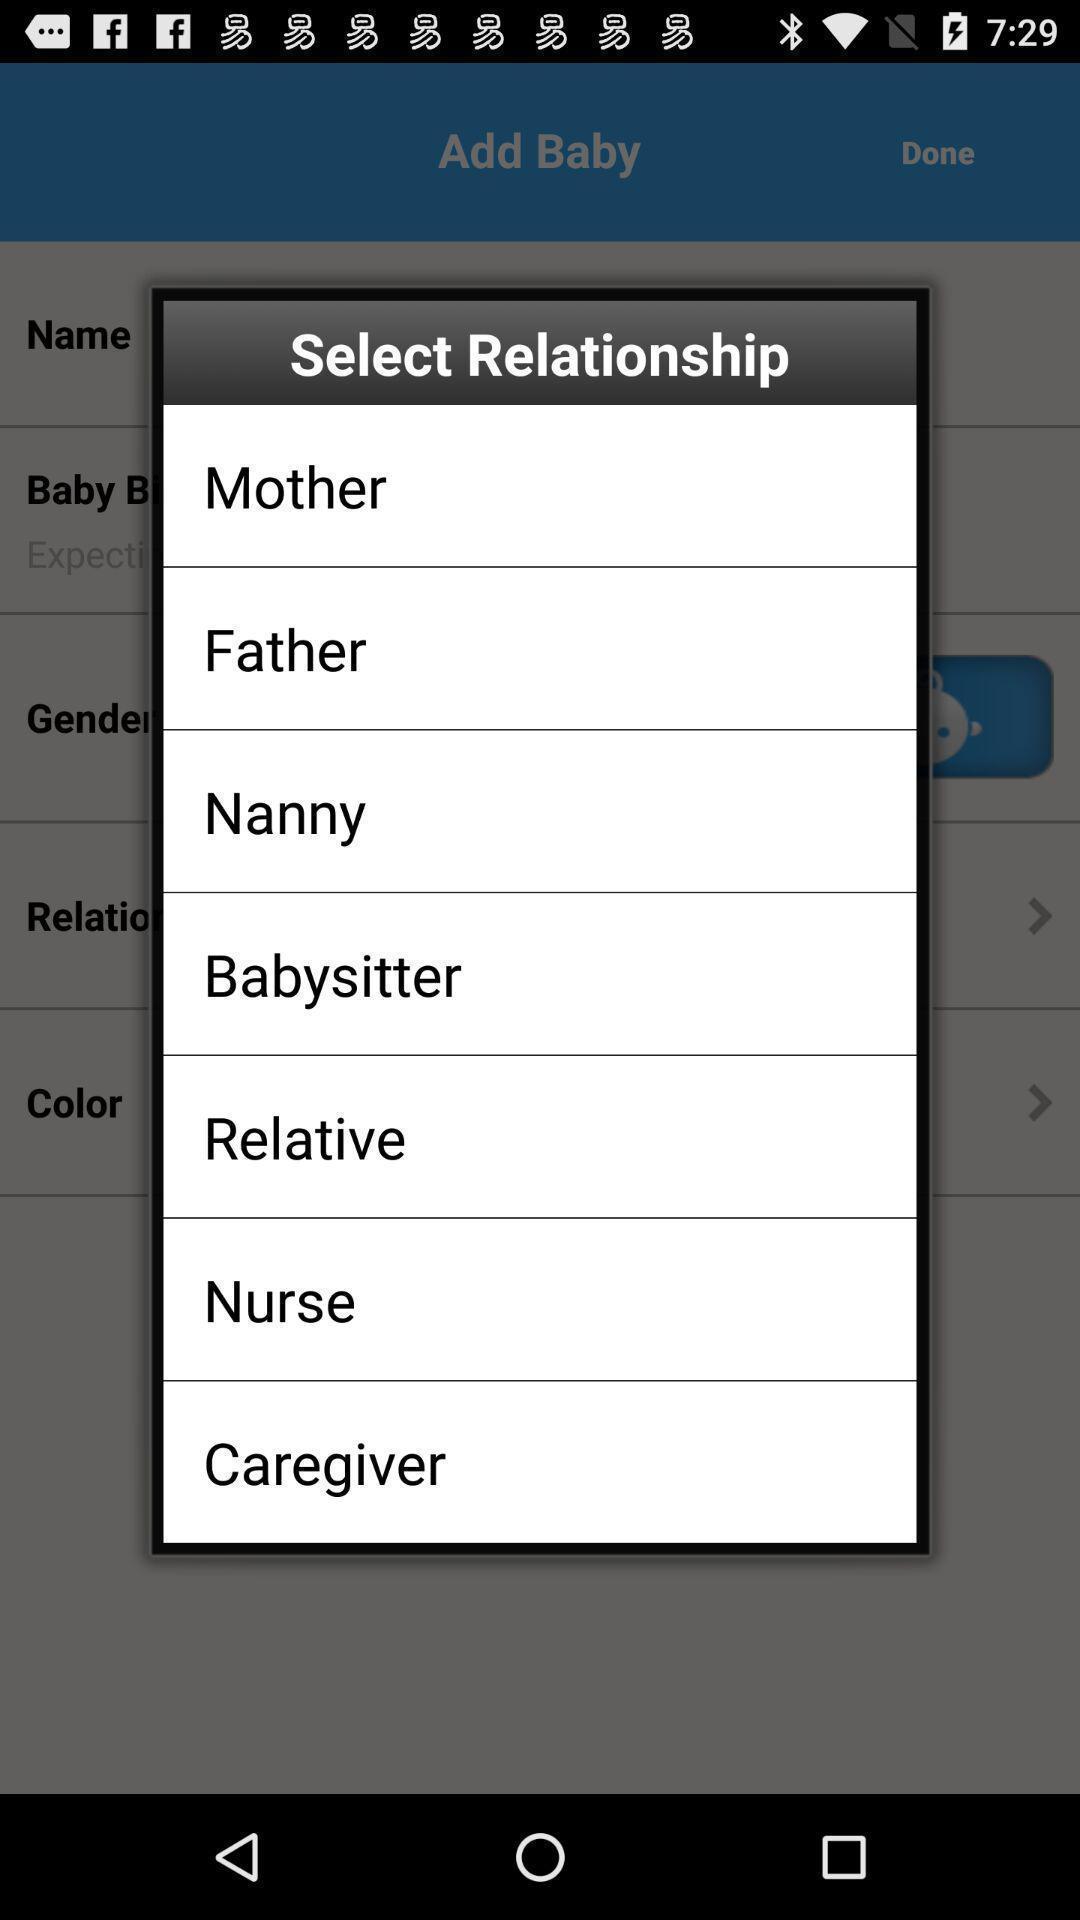Provide a description of this screenshot. Pop-up shows select relationship from list. 